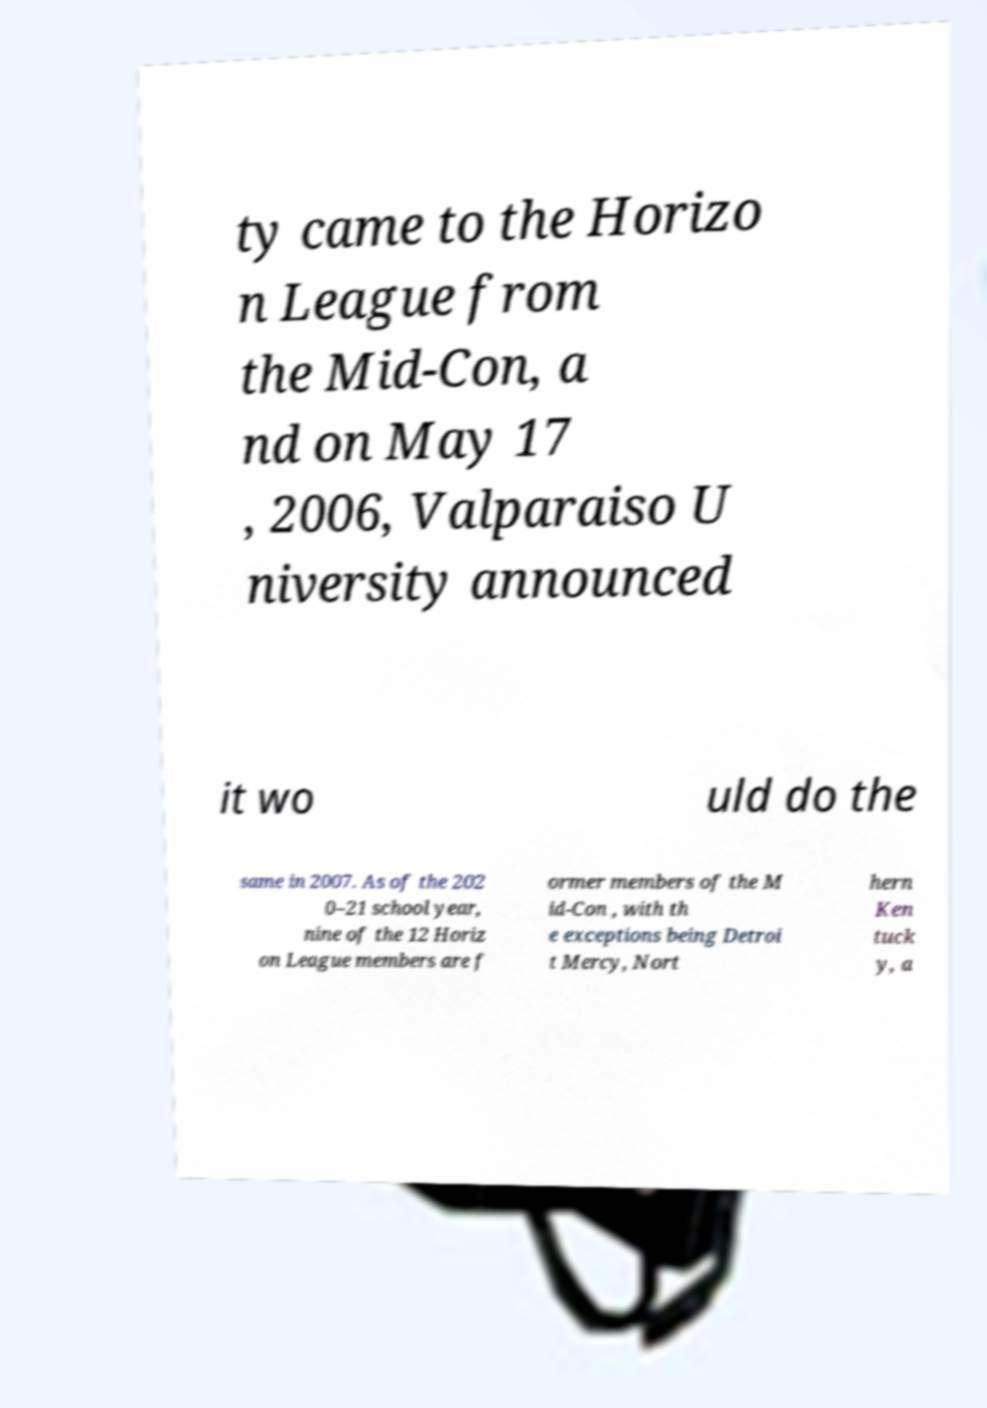Can you accurately transcribe the text from the provided image for me? ty came to the Horizo n League from the Mid-Con, a nd on May 17 , 2006, Valparaiso U niversity announced it wo uld do the same in 2007. As of the 202 0–21 school year, nine of the 12 Horiz on League members are f ormer members of the M id-Con , with th e exceptions being Detroi t Mercy, Nort hern Ken tuck y, a 